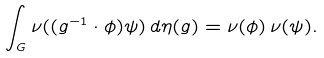<formula> <loc_0><loc_0><loc_500><loc_500>\int _ { G } \nu ( ( g ^ { - 1 } \cdot \phi ) \psi ) \, d \eta ( g ) = \nu ( \phi ) \, \nu ( \psi ) .</formula> 